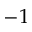Convert formula to latex. <formula><loc_0><loc_0><loc_500><loc_500>- 1</formula> 